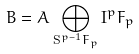<formula> <loc_0><loc_0><loc_500><loc_500>B = A \bigoplus _ { \mathbf S ^ { p - 1 } F _ { p } } \mathbf I ^ { p } F _ { p }</formula> 